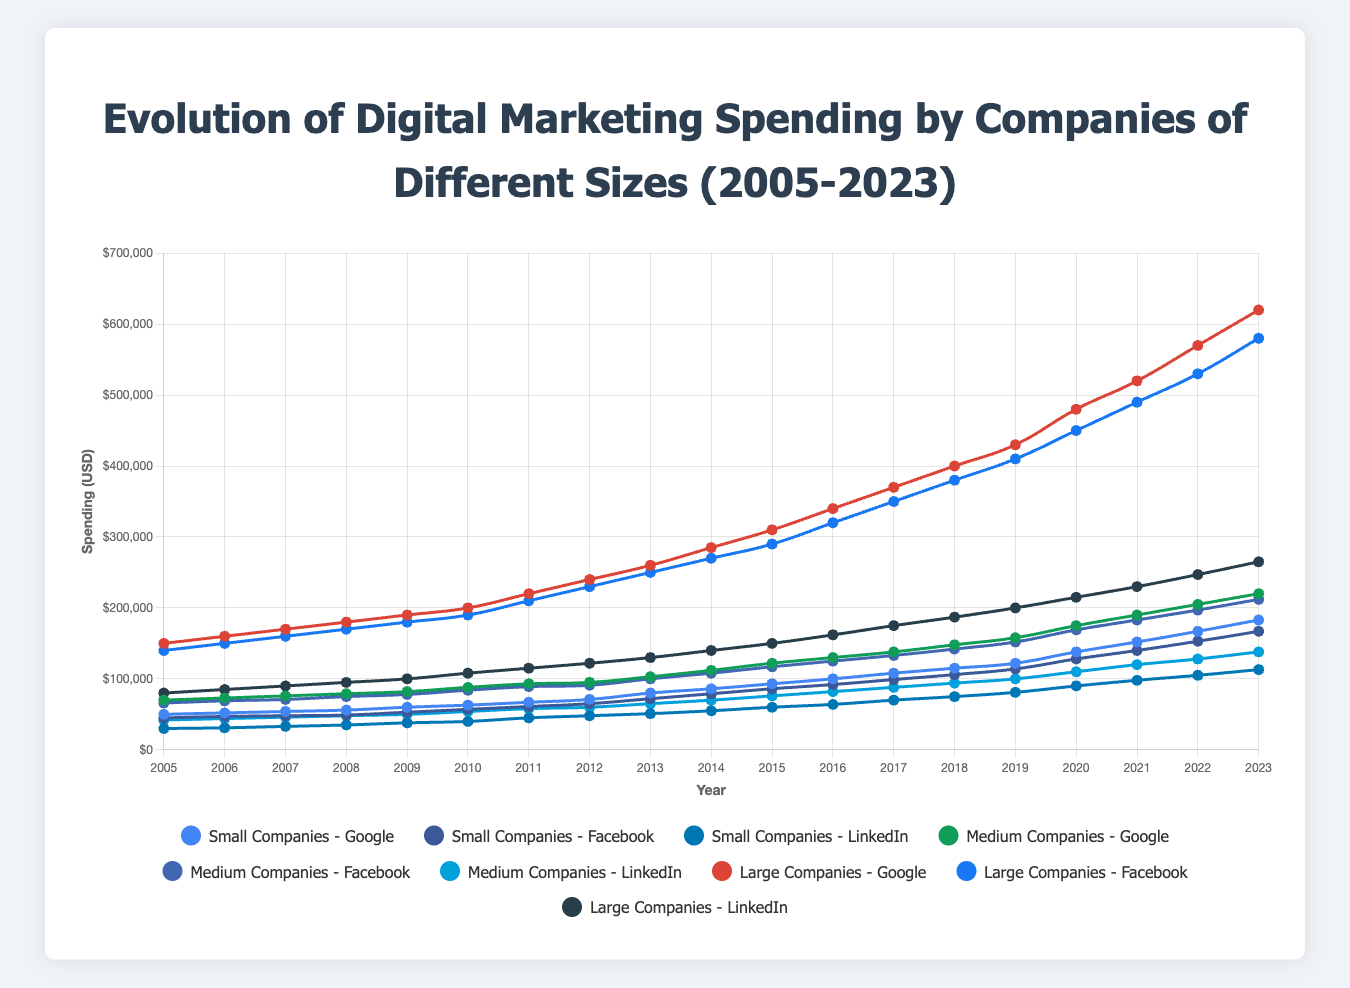What was the spending of medium-sized companies on Google and Facebook in 2010? The spending of medium-sized companies on Google in 2010 was $88,000 and on Facebook was $84,000. These values can be read directly from the chart at the intersection of the respective lines for medium-sized Google and Facebook at the year 2010.
Answer: Medium-sized companies: Google: $88,000, Facebook: $84,000 Which year had the largest increase in spending for small companies on LinkedIn? Look at the slope of the line representing small companies’ spending on LinkedIn for each year. The steepest slope signifies the largest increase. The year between 2014 and 2015 shows the largest increase, where spending increased from $55,000 to $60,000.
Answer: 2014-2015 How does the 2023 spending of large companies on Facebook compare to that on Google? In 2023, large companies' spending on Facebook was $580,000 and on Google was $620,000. Comparing these, Facebook spending is $40,000 less than Google spending.
Answer: $40,000 less What is the difference in spending between small-company Google and Facebook in 2023? For 2023, small-company Google spent $183,000 and small-company Facebook spent $167,000. The difference in spending is $183,000 - $167,000 = $16,000.
Answer: $16,000 What has been the general trend in spending for medium companies on LinkedIn from 2005 to 2023? Observing the line representing medium companies’ spending on LinkedIn, the general trend is an increase. Starting at $42,000 in 2005 and reaching $138,000 by 2023, it indicates a steady upward trend.
Answer: General upward trend Compare the increase in spending for large companies on Google and Facebook between 2015 and 2020. For large companies, Google’s spending in 2015 was $310,000 and in 2020 was $480,000. The increase is $480,000 - $310,000 = $170,000. Facebook’s spending in 2015 was $290,000 and in 2020 was $450,000. The increase is $450,000 - $290,000 = $160,000. Comparing these, Google spending increase is $10,000 more than Facebook.
Answer: Google increased by $10,000 more What was the smallest expenditure for medium companies on Facebook and in which year did it occur? The smallest expenditure for medium companies on Facebook was $66,000, which occurred in 2005. This value can be read directly from the start of the line representing medium-sized Facebook spending.
Answer: $66,000 in 2005 